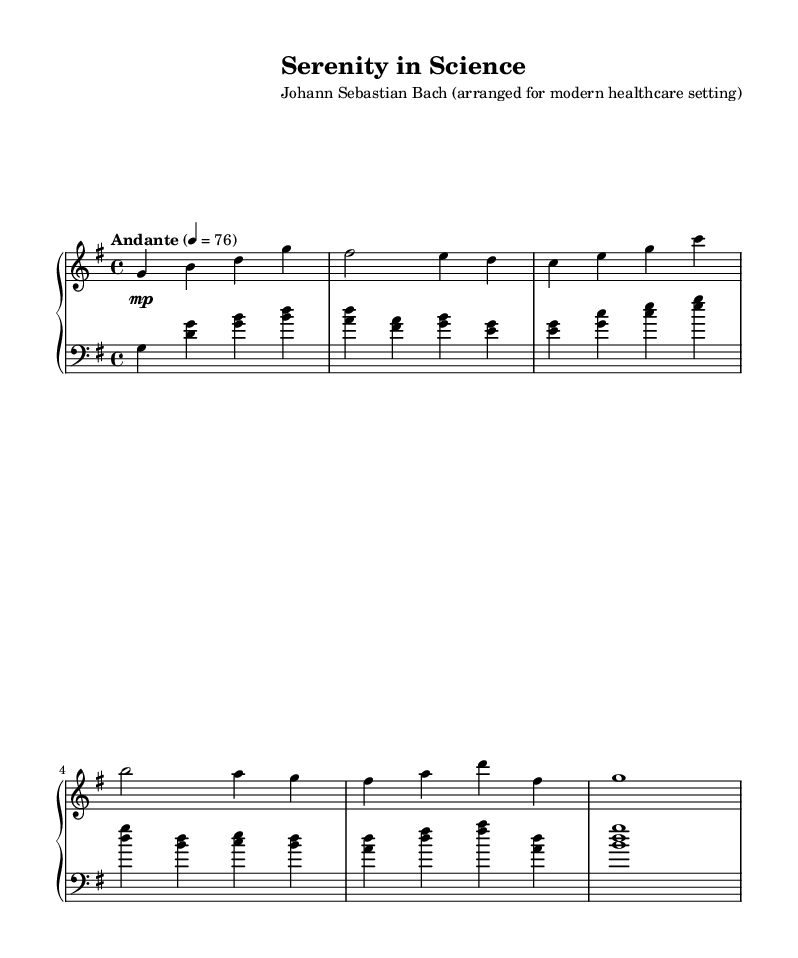What is the key signature of this music? The key signature is G major, which contains one sharp (F#). This is indicated by the placement of the sharp on the staff, showing that all F notes should be played as F sharp.
Answer: G major What is the time signature of the piece? The time signature is 4/4, which is represented as a fraction with a '4' on the top and bottom. This means there are four beats in each measure and the quarter note gets one beat.
Answer: 4/4 What is the tempo marking of the piece? The tempo marking is "Andante," which indicates a moderate speed of play, typically around 76 beats per minute, as noted on the sheet music.
Answer: Andante How many measures are in the right-hand part? The right-hand part consists of six measures. By counting each separate group of notes between the vertical lines that signify measures, we find six distinct segments.
Answer: 6 What is the highest note in the left-hand part? The highest note in the left-hand part is G above middle C. By identifying the notes on the staff from bottom to top, we can observe that G appears at the top of the left-hand segment.
Answer: G Is there a dynamic marking in the music? If so, what is it? Yes, there is a dynamic marking indicating "mp," which stands for "mezzo-piano," meaning moderately soft. This marking is placed at the beginning to guide the performer’s volume throughout the piece.
Answer: mp 